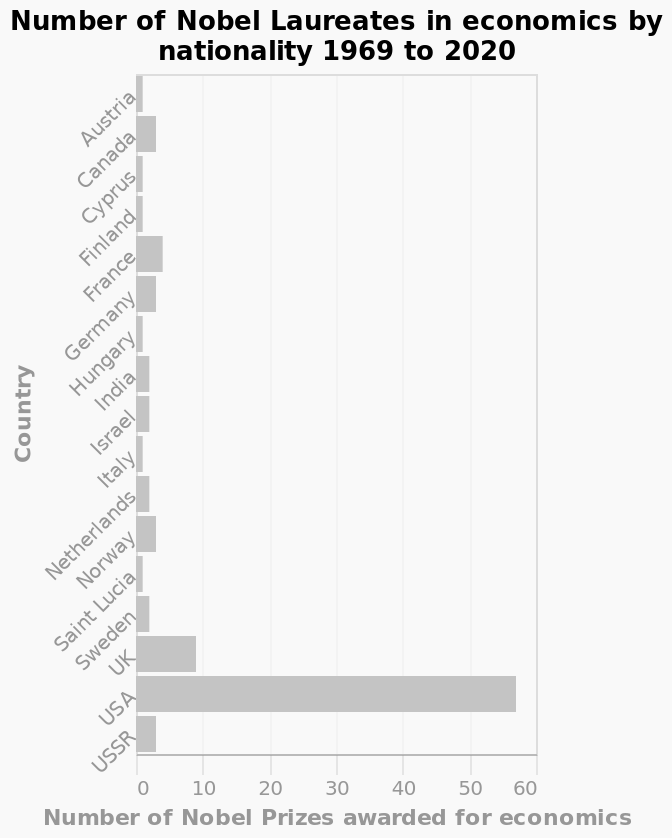<image>
Which country has the highest number of laureates since 1969?  The USA has the highest number of laureates since 1969. What does the bar graph depict?  The bar graph depicts the number of Nobel Laureates in economics by nationality from 1969 to 2020. What is the timeframe covered by the bar graph? The bar graph covers the period from 1969 to 2020. Which country has the third highest number of laureates since 1969?  France has the third highest number of laureates since 1969. 